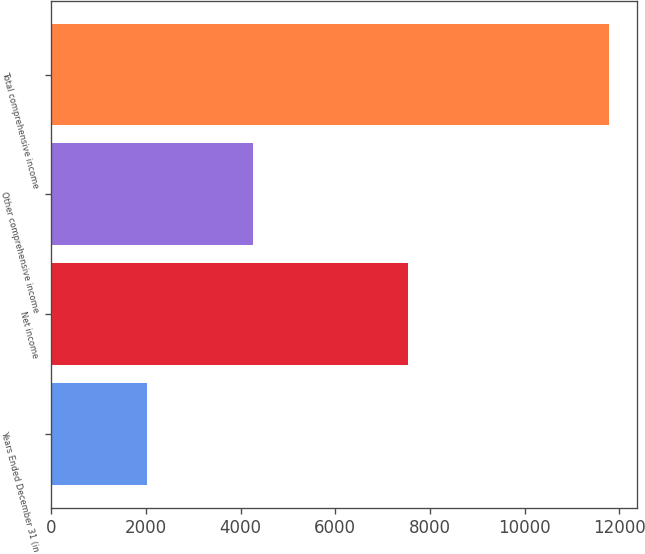Convert chart to OTSL. <chart><loc_0><loc_0><loc_500><loc_500><bar_chart><fcel>Years Ended December 31 (in<fcel>Net income<fcel>Other comprehensive income<fcel>Total comprehensive income<nl><fcel>2014<fcel>7529<fcel>4257<fcel>11786<nl></chart> 